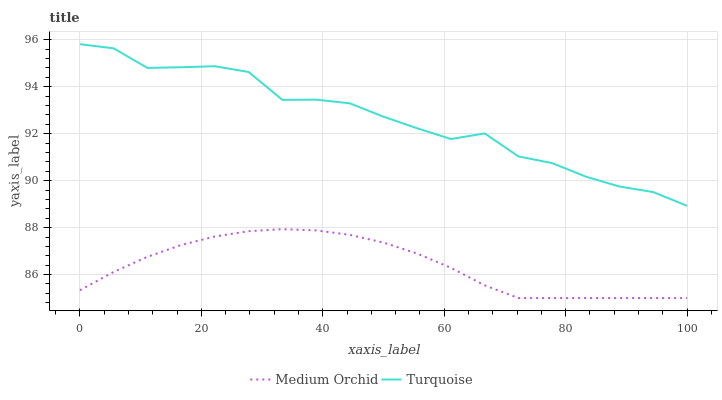Does Medium Orchid have the minimum area under the curve?
Answer yes or no. Yes. Does Turquoise have the maximum area under the curve?
Answer yes or no. Yes. Does Medium Orchid have the maximum area under the curve?
Answer yes or no. No. Is Medium Orchid the smoothest?
Answer yes or no. Yes. Is Turquoise the roughest?
Answer yes or no. Yes. Is Medium Orchid the roughest?
Answer yes or no. No. Does Medium Orchid have the lowest value?
Answer yes or no. Yes. Does Turquoise have the highest value?
Answer yes or no. Yes. Does Medium Orchid have the highest value?
Answer yes or no. No. Is Medium Orchid less than Turquoise?
Answer yes or no. Yes. Is Turquoise greater than Medium Orchid?
Answer yes or no. Yes. Does Medium Orchid intersect Turquoise?
Answer yes or no. No. 